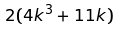Convert formula to latex. <formula><loc_0><loc_0><loc_500><loc_500>2 ( 4 k ^ { 3 } + 1 1 k )</formula> 